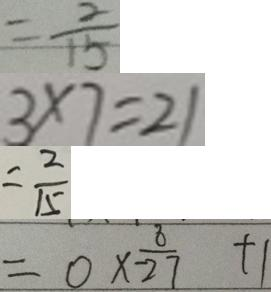<formula> <loc_0><loc_0><loc_500><loc_500>= \frac { 2 } { 1 5 } 
 3 \times 7 = 2 1 
 = \frac { 2 } { 1 5 } 
 = 0 \times \frac { 8 } { - 2 7 } + 1</formula> 